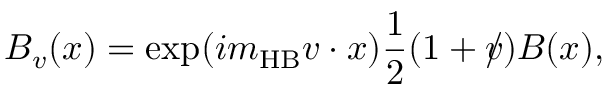Convert formula to latex. <formula><loc_0><loc_0><loc_500><loc_500>B _ { v } ( x ) = \exp ( i m _ { H B } v \cdot { x } ) \frac { 1 } { 2 } ( 1 + v \, / ) B ( x ) ,</formula> 